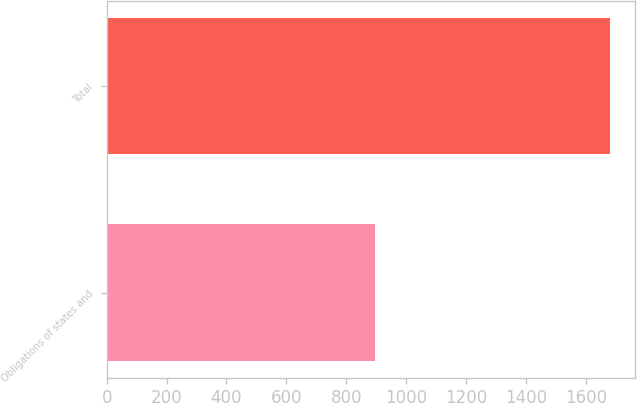<chart> <loc_0><loc_0><loc_500><loc_500><bar_chart><fcel>Obligations of states and<fcel>Total<nl><fcel>897<fcel>1680<nl></chart> 